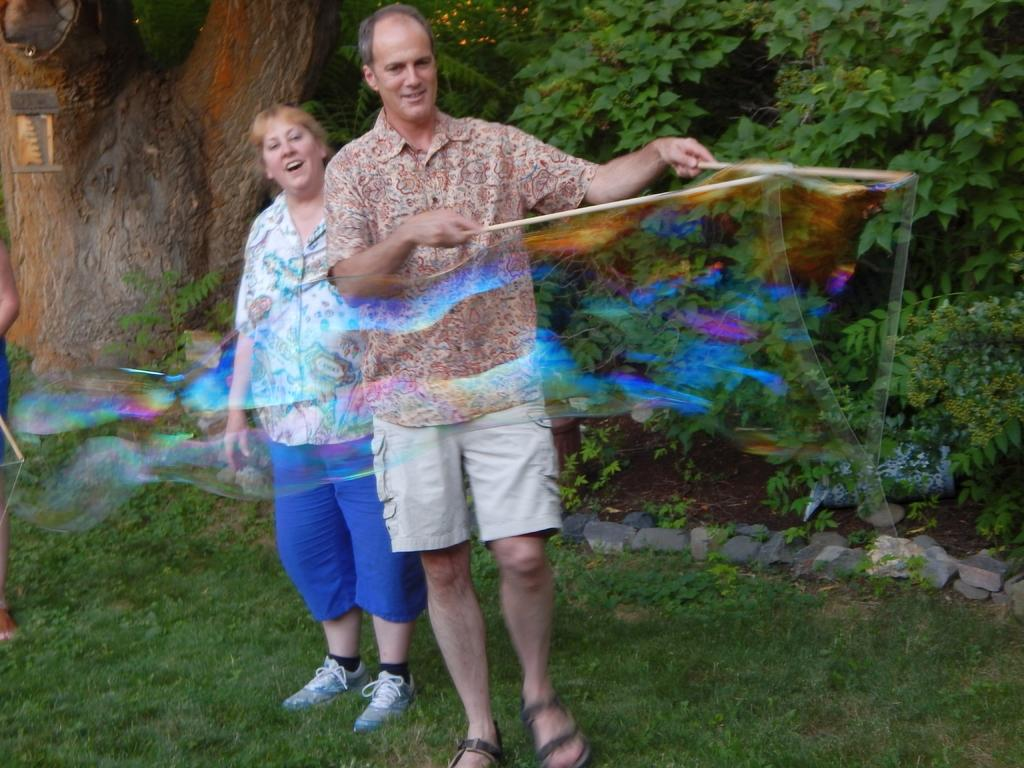How many people are in the image? There are two people in the image, a man and a woman. What is the man holding in the image? The man is holding sticks. What can be seen in the background of the image? There are trees in the background of the image. What type of vegetation is at the bottom of the image? There is grass at the bottom of the image. What is the unusual object visible in the image? There is a bubble visible in the image. What type of apparel is the snail wearing in the image? There is no snail present in the image, and therefore no apparel can be observed. How many ladybugs can be seen interacting with the bubble in the image? There are no ladybugs present in the image, and therefore no interaction with the bubble can be observed. 